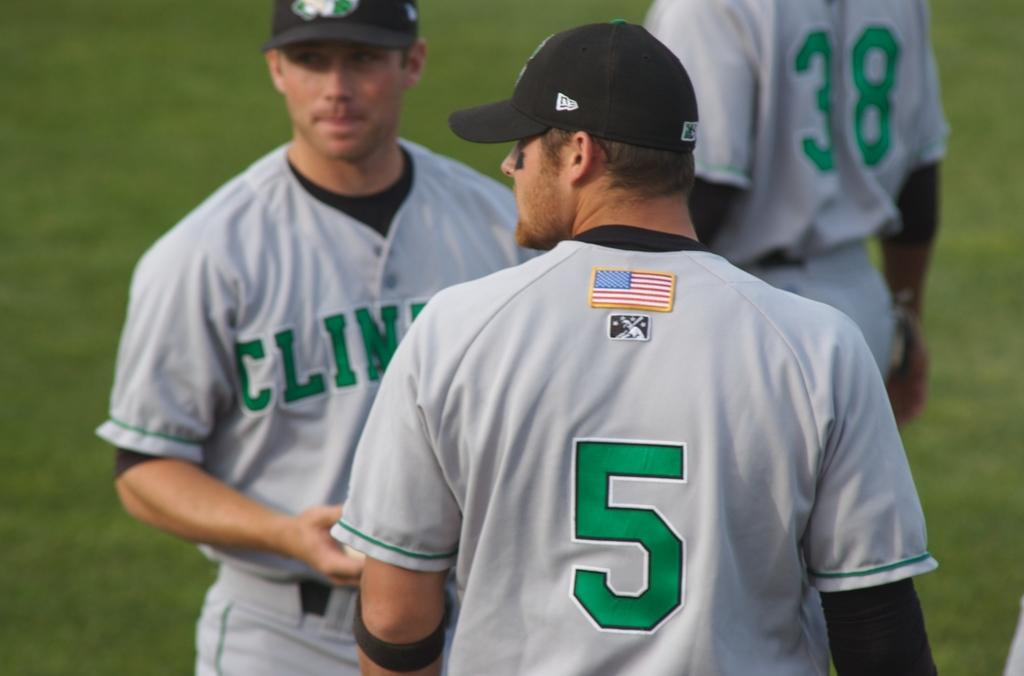<image>
Write a terse but informative summary of the picture. a player with the number 5 on their jersey with others 